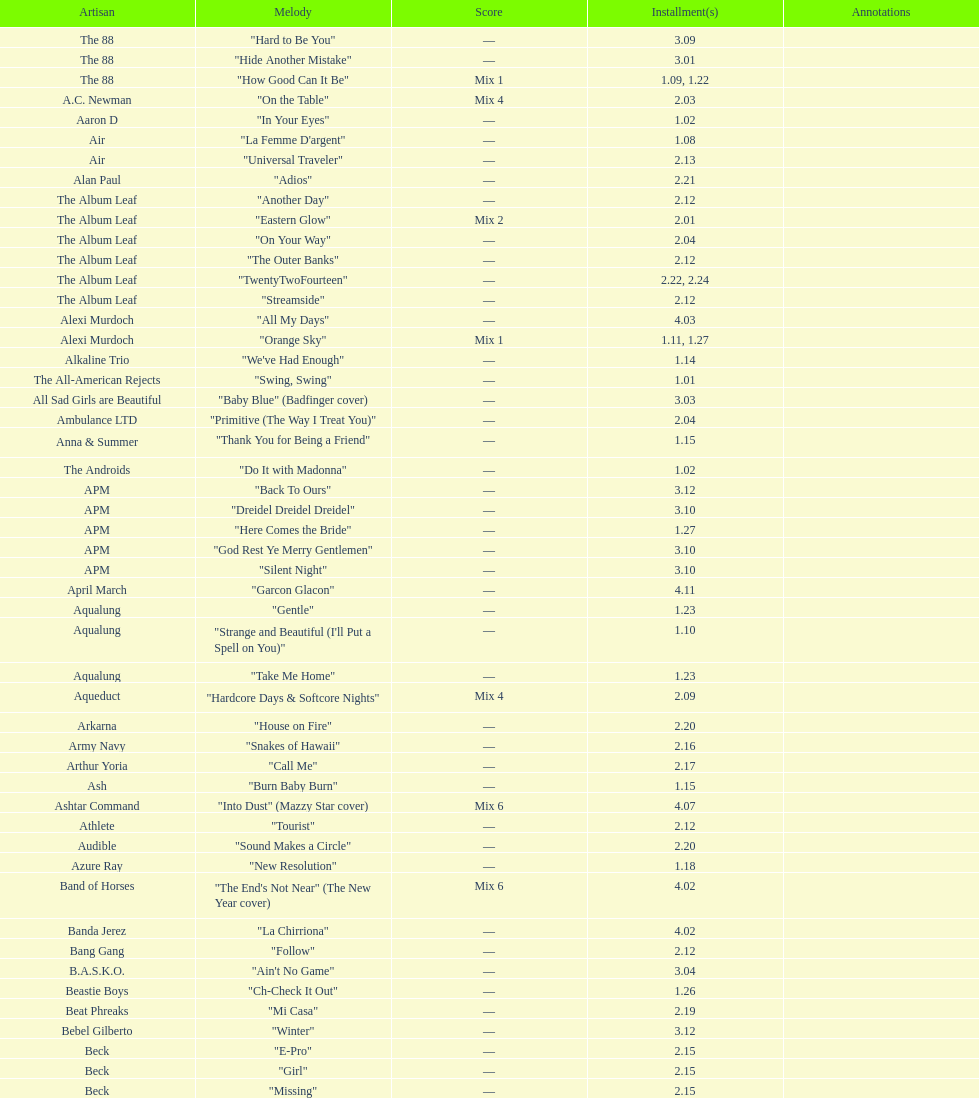What artist has more music appear in the show, daft punk or franz ferdinand? Franz Ferdinand. 